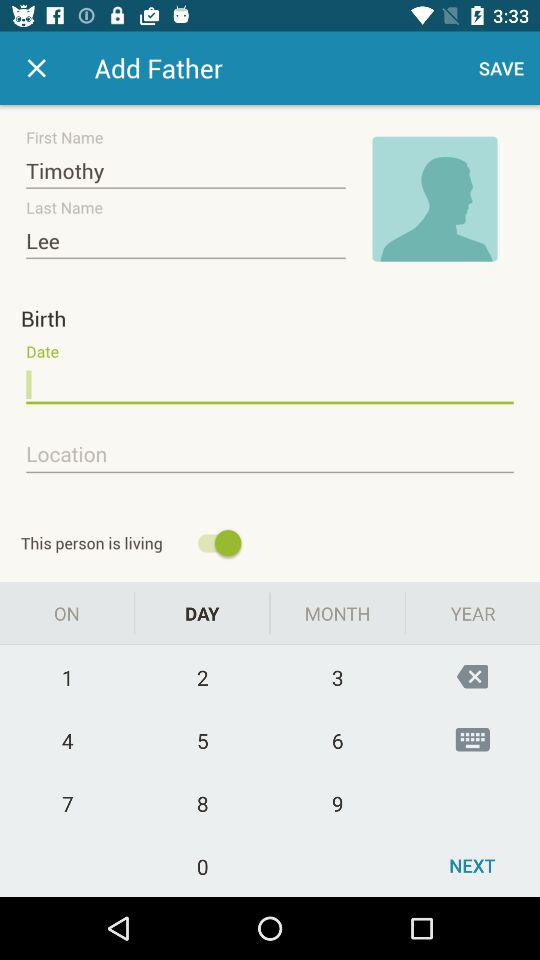How many text inputs are there for the father's name?
Answer the question using a single word or phrase. 2 